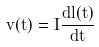Convert formula to latex. <formula><loc_0><loc_0><loc_500><loc_500>v ( t ) = I \frac { d l ( t ) } { d t }</formula> 